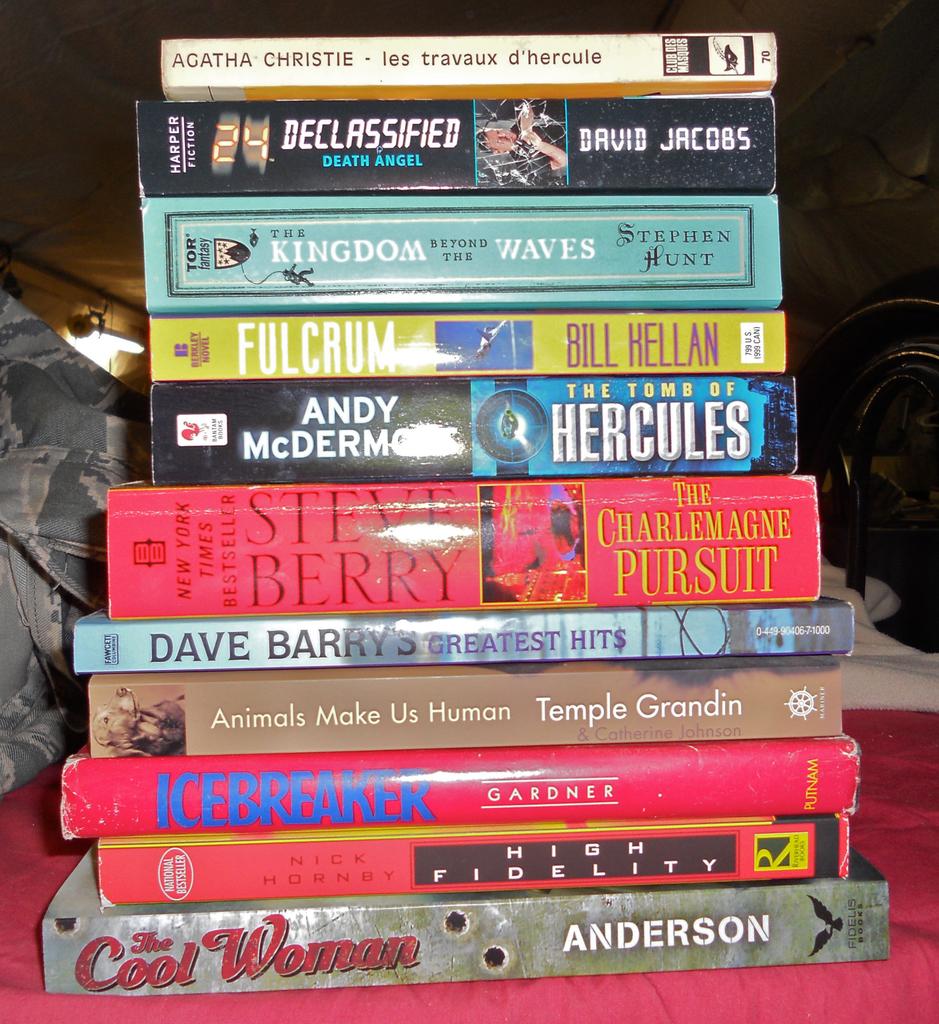Who wrote animals make us human?
Your answer should be compact. Temple grandin. What is the name of the last movie closest to the table?
Ensure brevity in your answer.  The cool woman. 